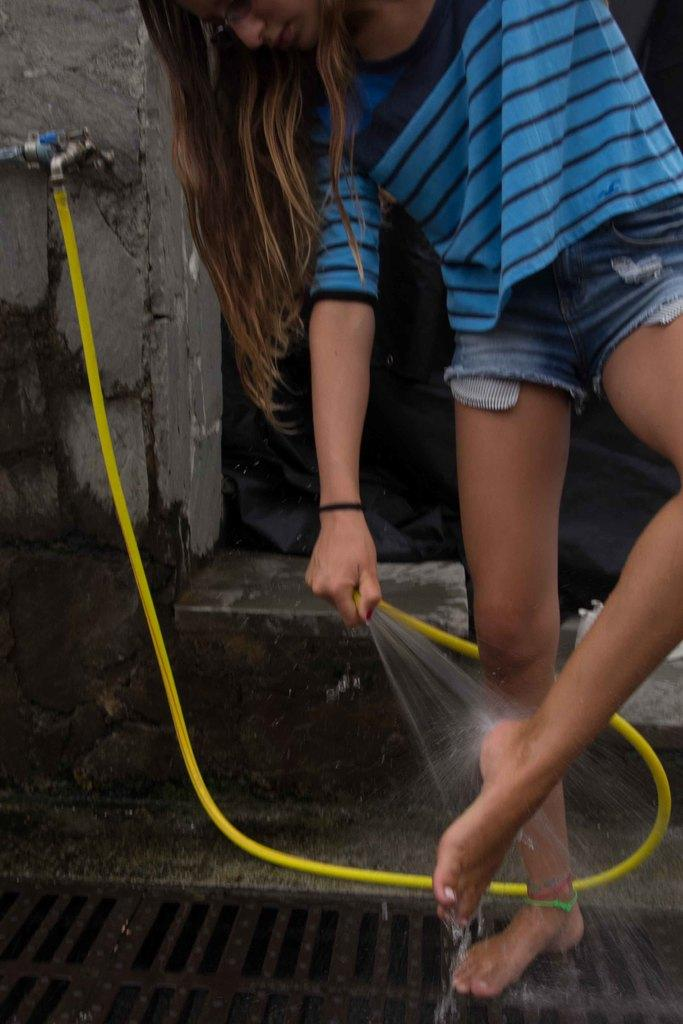Who is the main subject in the image? There is a girl in the image. What is the girl holding in her hand? The girl is holding a pipe in her hand. What is the girl standing on? The girl is standing on a mesh. What is the source of water in the image? A tap is present in the image. What is the state of the water in the image? Water is visible in the image. What type of table is visible in the image? There is no table present in the image. Is the girl wearing a suit in the image? The provided facts do not mention the girl's clothing, so we cannot determine if she is wearing a suit or not. 